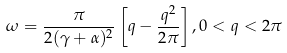<formula> <loc_0><loc_0><loc_500><loc_500>\omega = \frac { \pi } { 2 ( \gamma + \alpha ) ^ { 2 } } \left [ q - \frac { q ^ { 2 } } { 2 \pi } \right ] , 0 < q < 2 \pi</formula> 